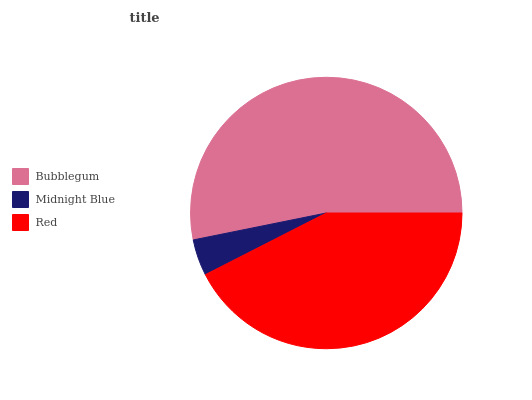Is Midnight Blue the minimum?
Answer yes or no. Yes. Is Bubblegum the maximum?
Answer yes or no. Yes. Is Red the minimum?
Answer yes or no. No. Is Red the maximum?
Answer yes or no. No. Is Red greater than Midnight Blue?
Answer yes or no. Yes. Is Midnight Blue less than Red?
Answer yes or no. Yes. Is Midnight Blue greater than Red?
Answer yes or no. No. Is Red less than Midnight Blue?
Answer yes or no. No. Is Red the high median?
Answer yes or no. Yes. Is Red the low median?
Answer yes or no. Yes. Is Midnight Blue the high median?
Answer yes or no. No. Is Midnight Blue the low median?
Answer yes or no. No. 